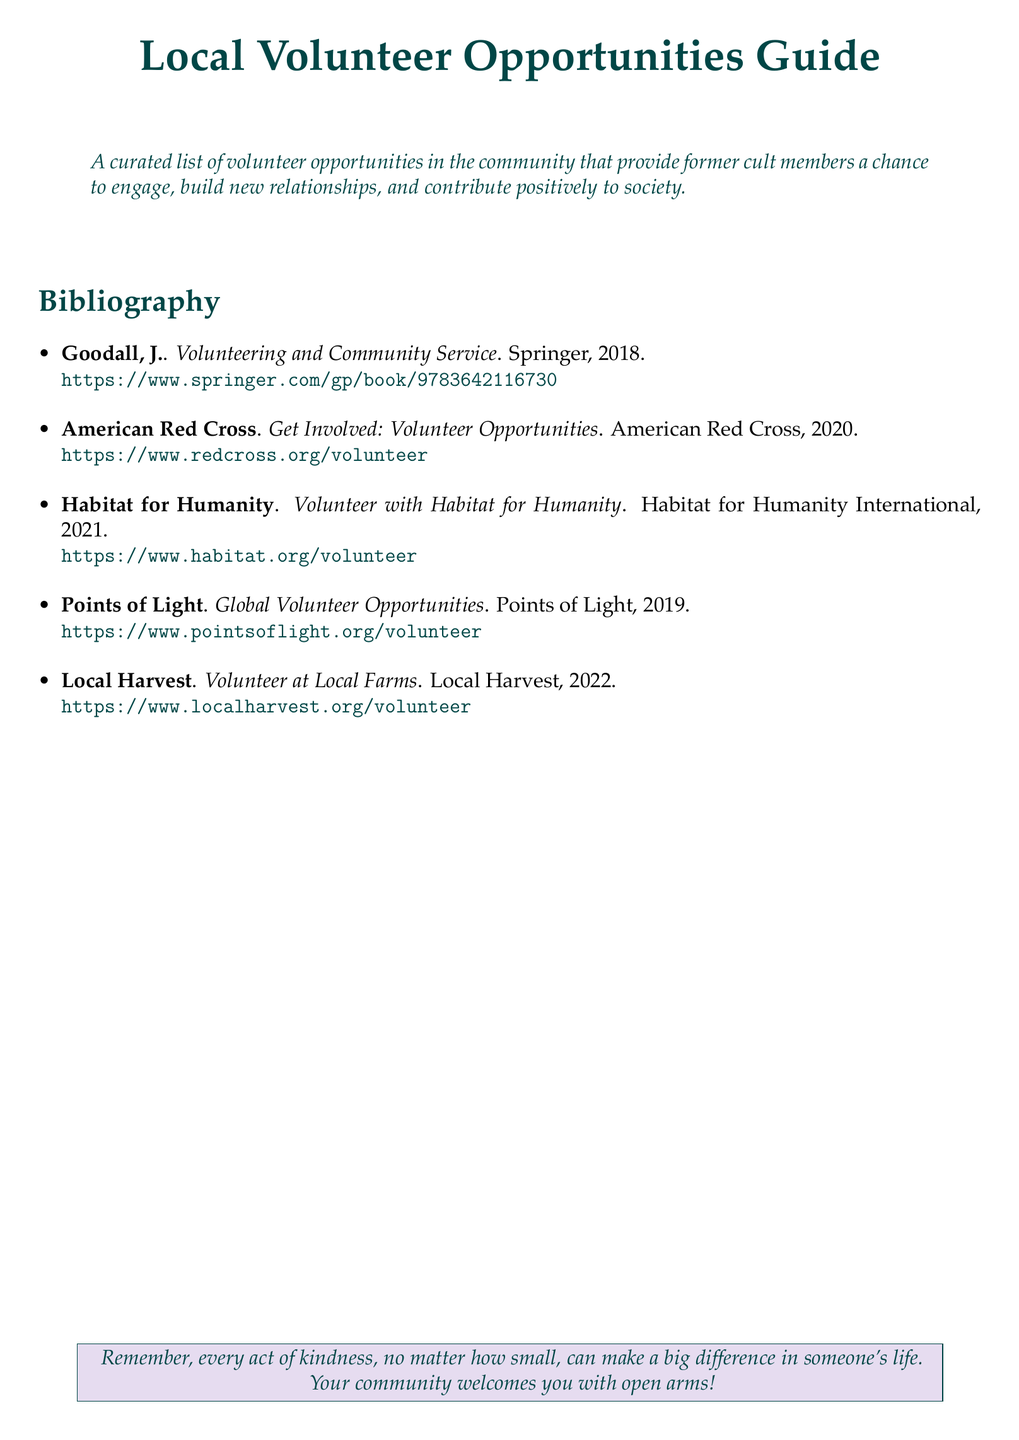What is the title of the guide? The title of the guide is found at the top of the document and is explicitly stated.
Answer: Local Volunteer Opportunities Guide Who is the author of the book "Volunteering and Community Service"? The author is mentioned in the bibliography entry for the book.
Answer: Goodall, J What is the publication year of the American Red Cross volunteer opportunities? The publication year is noted in the entry for the American Red Cross.
Answer: 2020 How many volunteer organizations are listed in the bibliography? By counting the entries in the bibliography, the total number can be determined.
Answer: 5 What is the purpose of the Local Volunteer Opportunities Guide? This purpose is described in the introductory quote of the document.
Answer: Provide a chance to engage, build new relationships, and contribute positively to society Which organization focuses on building homes? The specific organization is identified in the title of its bibliography entry.
Answer: Habitat for Humanity What type of document is this bibliography from? The type of document is indicated in the explicit context of the document formatting and title.
Answer: Bibliography Where can I find the volunteer opportunities with Local Harvest? The specific URL is provided in the bibliography entry for Local Harvest.
Answer: https://www.localharvest.org/volunteer 